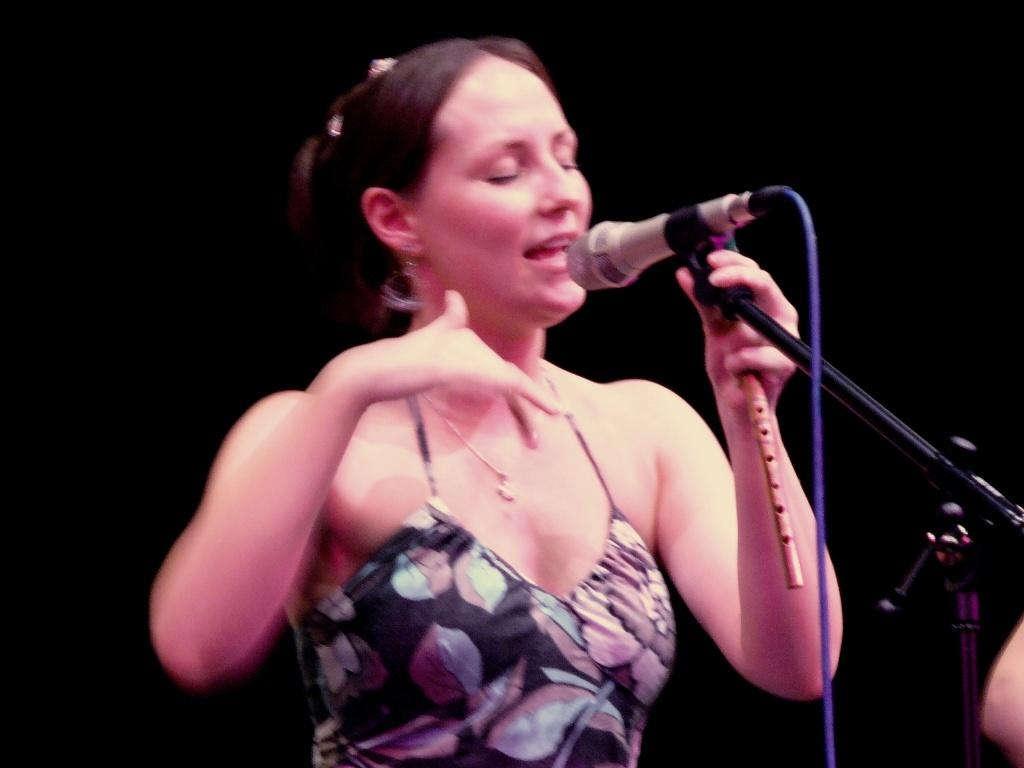Who is the main subject in the image? There is a woman in the image. What is the woman doing in the image? The woman is singing in the image. What tool is the woman using while singing? The woman is using a microphone in the image. What type of hook can be seen on the wall behind the woman in the image? There is no hook visible on the wall behind the woman in the image. 